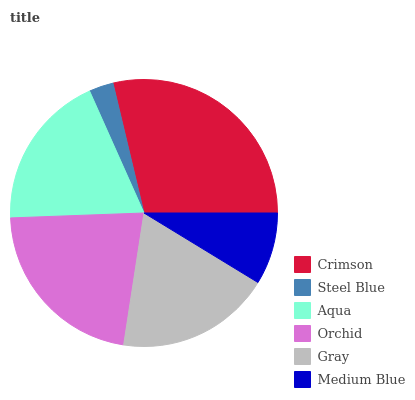Is Steel Blue the minimum?
Answer yes or no. Yes. Is Crimson the maximum?
Answer yes or no. Yes. Is Aqua the minimum?
Answer yes or no. No. Is Aqua the maximum?
Answer yes or no. No. Is Aqua greater than Steel Blue?
Answer yes or no. Yes. Is Steel Blue less than Aqua?
Answer yes or no. Yes. Is Steel Blue greater than Aqua?
Answer yes or no. No. Is Aqua less than Steel Blue?
Answer yes or no. No. Is Aqua the high median?
Answer yes or no. Yes. Is Gray the low median?
Answer yes or no. Yes. Is Crimson the high median?
Answer yes or no. No. Is Aqua the low median?
Answer yes or no. No. 